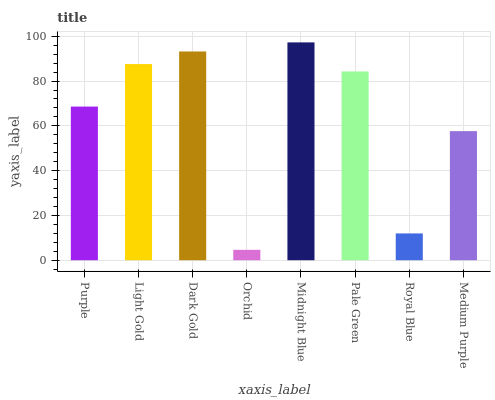Is Orchid the minimum?
Answer yes or no. Yes. Is Midnight Blue the maximum?
Answer yes or no. Yes. Is Light Gold the minimum?
Answer yes or no. No. Is Light Gold the maximum?
Answer yes or no. No. Is Light Gold greater than Purple?
Answer yes or no. Yes. Is Purple less than Light Gold?
Answer yes or no. Yes. Is Purple greater than Light Gold?
Answer yes or no. No. Is Light Gold less than Purple?
Answer yes or no. No. Is Pale Green the high median?
Answer yes or no. Yes. Is Purple the low median?
Answer yes or no. Yes. Is Dark Gold the high median?
Answer yes or no. No. Is Light Gold the low median?
Answer yes or no. No. 